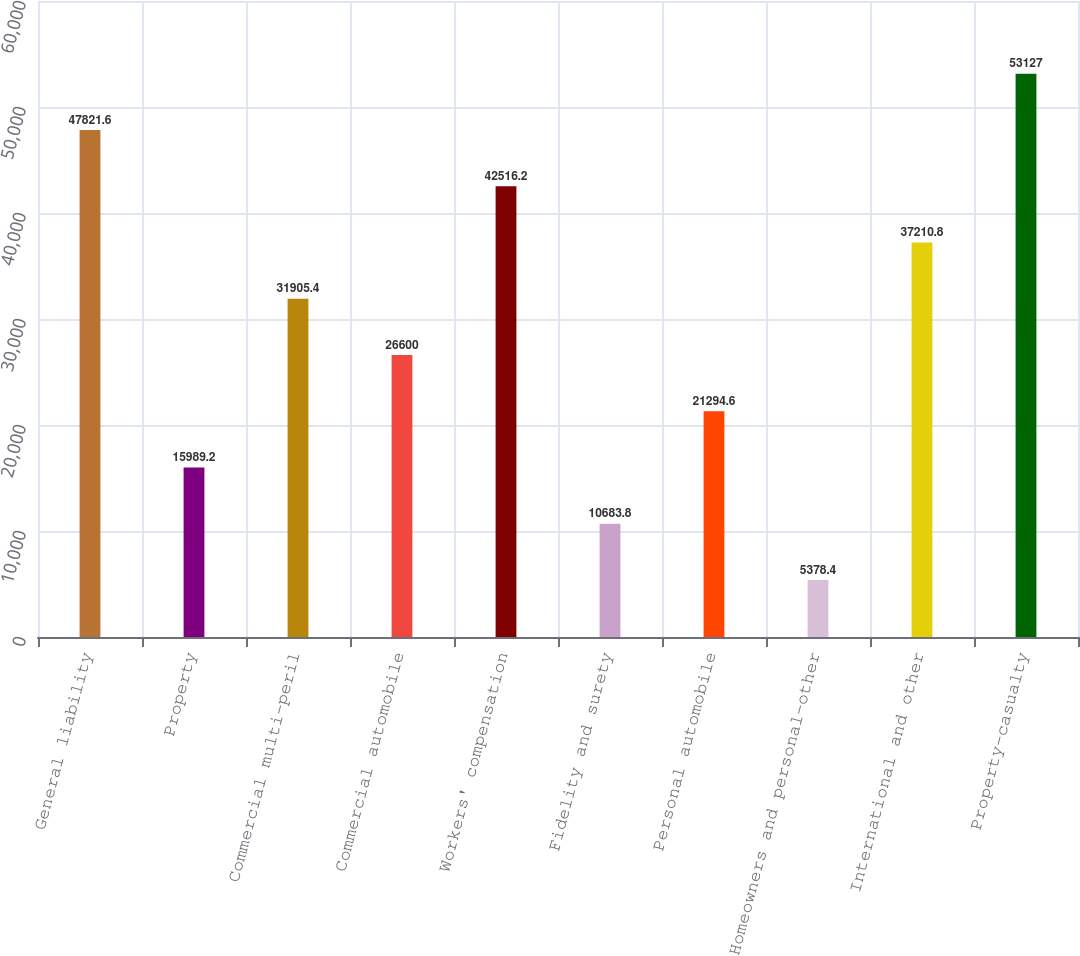Convert chart. <chart><loc_0><loc_0><loc_500><loc_500><bar_chart><fcel>General liability<fcel>Property<fcel>Commercial multi-peril<fcel>Commercial automobile<fcel>Workers' compensation<fcel>Fidelity and surety<fcel>Personal automobile<fcel>Homeowners and personal-other<fcel>International and other<fcel>Property-casualty<nl><fcel>47821.6<fcel>15989.2<fcel>31905.4<fcel>26600<fcel>42516.2<fcel>10683.8<fcel>21294.6<fcel>5378.4<fcel>37210.8<fcel>53127<nl></chart> 